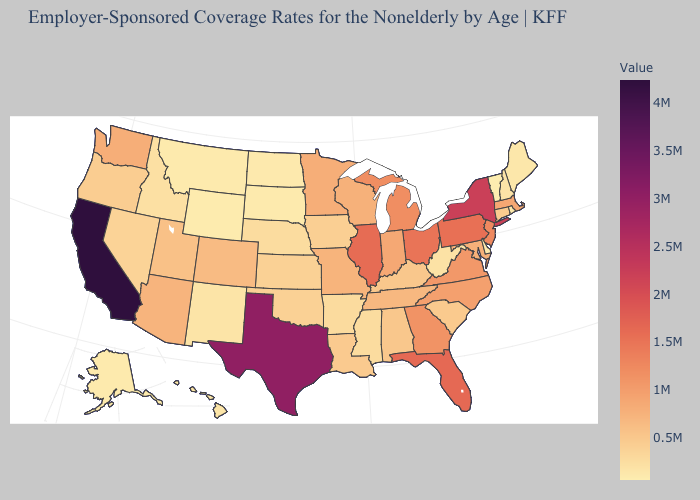Among the states that border Utah , which have the lowest value?
Be succinct. Wyoming. Does Missouri have a lower value than Vermont?
Answer briefly. No. Does Vermont have the lowest value in the USA?
Keep it brief. Yes. Among the states that border North Dakota , which have the highest value?
Answer briefly. Minnesota. 